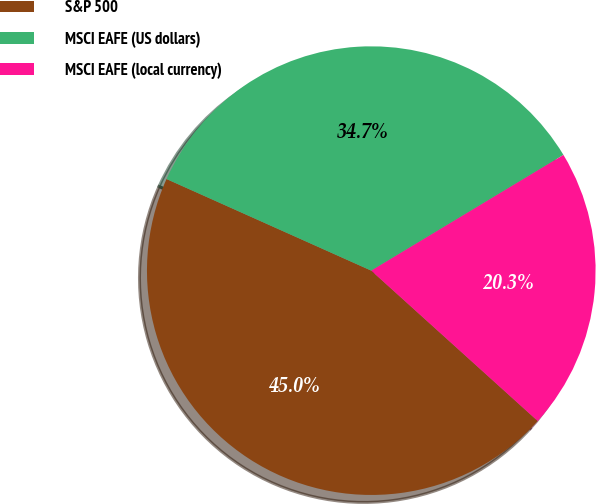Convert chart. <chart><loc_0><loc_0><loc_500><loc_500><pie_chart><fcel>S&P 500<fcel>MSCI EAFE (US dollars)<fcel>MSCI EAFE (local currency)<nl><fcel>45.01%<fcel>34.68%<fcel>20.32%<nl></chart> 